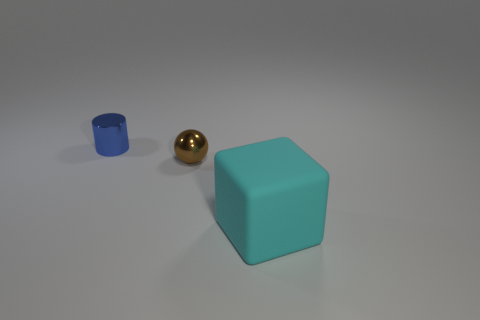What is the largest object in this image and what color is it? The largest object in the image is a cube with a calming teal color, standing prominently with its distinctly solid shape and uniform color. 